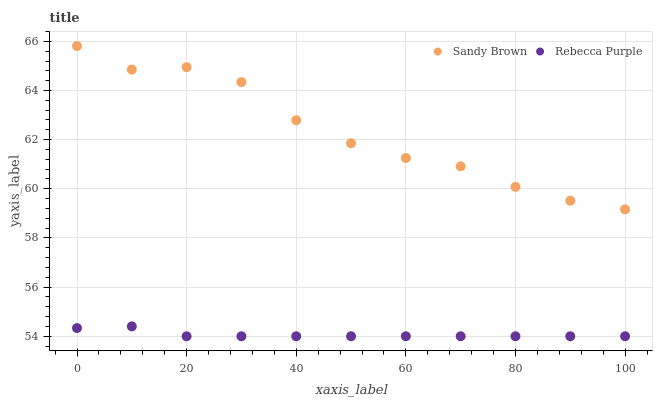Does Rebecca Purple have the minimum area under the curve?
Answer yes or no. Yes. Does Sandy Brown have the maximum area under the curve?
Answer yes or no. Yes. Does Rebecca Purple have the maximum area under the curve?
Answer yes or no. No. Is Rebecca Purple the smoothest?
Answer yes or no. Yes. Is Sandy Brown the roughest?
Answer yes or no. Yes. Is Rebecca Purple the roughest?
Answer yes or no. No. Does Rebecca Purple have the lowest value?
Answer yes or no. Yes. Does Sandy Brown have the highest value?
Answer yes or no. Yes. Does Rebecca Purple have the highest value?
Answer yes or no. No. Is Rebecca Purple less than Sandy Brown?
Answer yes or no. Yes. Is Sandy Brown greater than Rebecca Purple?
Answer yes or no. Yes. Does Rebecca Purple intersect Sandy Brown?
Answer yes or no. No. 